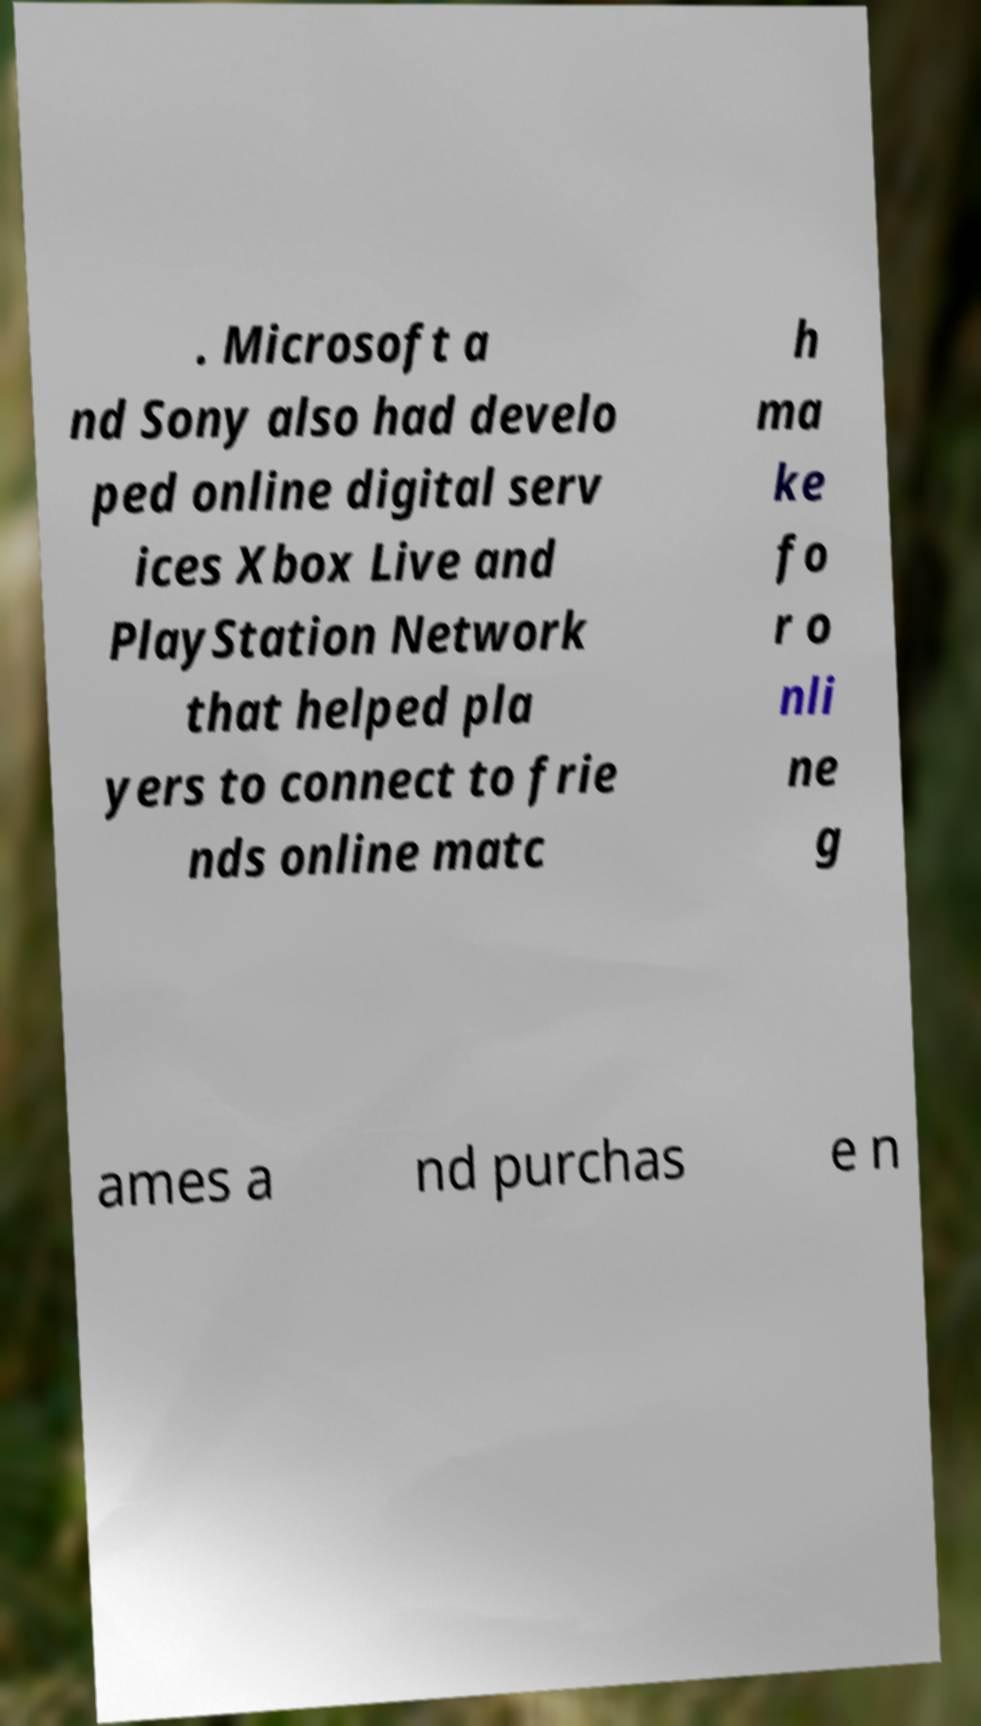What messages or text are displayed in this image? I need them in a readable, typed format. . Microsoft a nd Sony also had develo ped online digital serv ices Xbox Live and PlayStation Network that helped pla yers to connect to frie nds online matc h ma ke fo r o nli ne g ames a nd purchas e n 